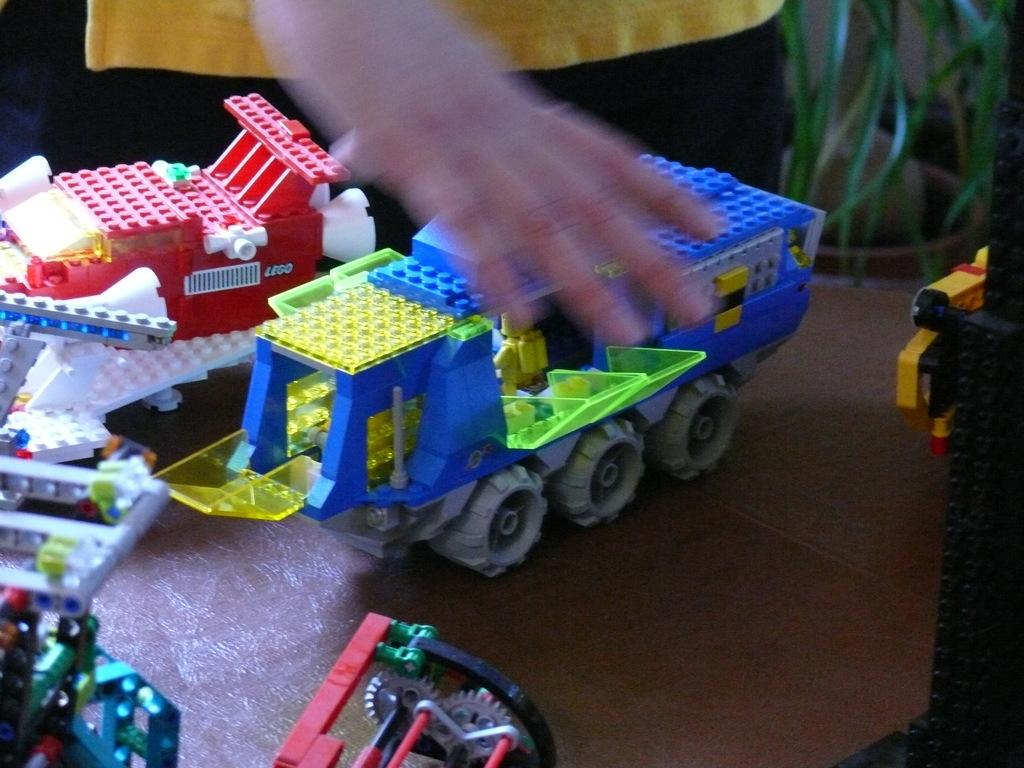What type of toys are on the table in the image? There are toys made with legos on the table. Can you describe the presence of any people in the image? Yes, there is a person in the background of the image. What type of plant is visible in the image? There is a houseplant on the right side of the image. What type of dress is the person wearing in the image? There is no person wearing a dress in the image; the person in the background is not visible in enough detail to determine their clothing. 